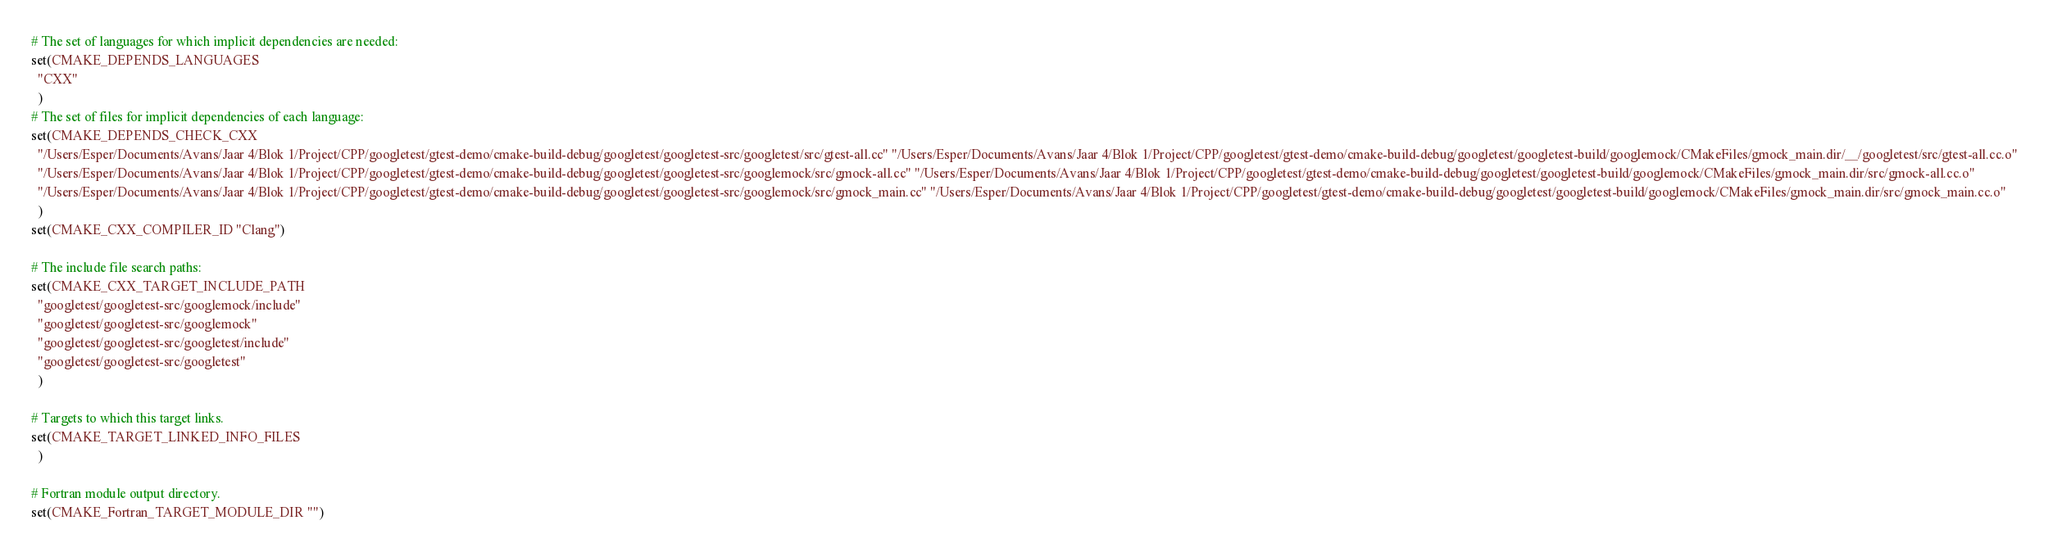Convert code to text. <code><loc_0><loc_0><loc_500><loc_500><_CMake_># The set of languages for which implicit dependencies are needed:
set(CMAKE_DEPENDS_LANGUAGES
  "CXX"
  )
# The set of files for implicit dependencies of each language:
set(CMAKE_DEPENDS_CHECK_CXX
  "/Users/Esper/Documents/Avans/Jaar 4/Blok 1/Project/CPP/googletest/gtest-demo/cmake-build-debug/googletest/googletest-src/googletest/src/gtest-all.cc" "/Users/Esper/Documents/Avans/Jaar 4/Blok 1/Project/CPP/googletest/gtest-demo/cmake-build-debug/googletest/googletest-build/googlemock/CMakeFiles/gmock_main.dir/__/googletest/src/gtest-all.cc.o"
  "/Users/Esper/Documents/Avans/Jaar 4/Blok 1/Project/CPP/googletest/gtest-demo/cmake-build-debug/googletest/googletest-src/googlemock/src/gmock-all.cc" "/Users/Esper/Documents/Avans/Jaar 4/Blok 1/Project/CPP/googletest/gtest-demo/cmake-build-debug/googletest/googletest-build/googlemock/CMakeFiles/gmock_main.dir/src/gmock-all.cc.o"
  "/Users/Esper/Documents/Avans/Jaar 4/Blok 1/Project/CPP/googletest/gtest-demo/cmake-build-debug/googletest/googletest-src/googlemock/src/gmock_main.cc" "/Users/Esper/Documents/Avans/Jaar 4/Blok 1/Project/CPP/googletest/gtest-demo/cmake-build-debug/googletest/googletest-build/googlemock/CMakeFiles/gmock_main.dir/src/gmock_main.cc.o"
  )
set(CMAKE_CXX_COMPILER_ID "Clang")

# The include file search paths:
set(CMAKE_CXX_TARGET_INCLUDE_PATH
  "googletest/googletest-src/googlemock/include"
  "googletest/googletest-src/googlemock"
  "googletest/googletest-src/googletest/include"
  "googletest/googletest-src/googletest"
  )

# Targets to which this target links.
set(CMAKE_TARGET_LINKED_INFO_FILES
  )

# Fortran module output directory.
set(CMAKE_Fortran_TARGET_MODULE_DIR "")
</code> 